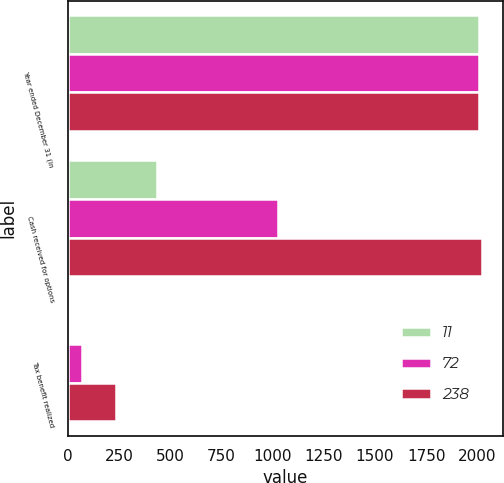Convert chart to OTSL. <chart><loc_0><loc_0><loc_500><loc_500><stacked_bar_chart><ecel><fcel>Year ended December 31 (in<fcel>Cash received for options<fcel>Tax benefit realized<nl><fcel>11<fcel>2009<fcel>437<fcel>11<nl><fcel>72<fcel>2008<fcel>1026<fcel>72<nl><fcel>238<fcel>2007<fcel>2023<fcel>238<nl></chart> 